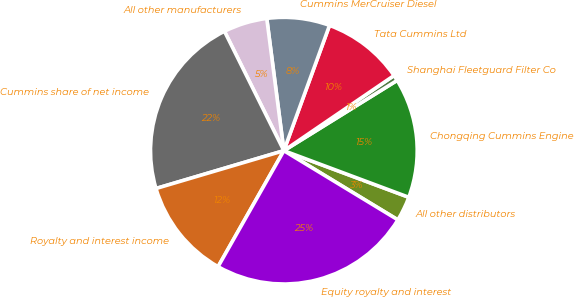Convert chart. <chart><loc_0><loc_0><loc_500><loc_500><pie_chart><fcel>All other distributors<fcel>Chongqing Cummins Engine<fcel>Shanghai Fleetguard Filter Co<fcel>Tata Cummins Ltd<fcel>Cummins MerCruiser Diesel<fcel>All other manufacturers<fcel>Cummins share of net income<fcel>Royalty and interest income<fcel>Equity royalty and interest<nl><fcel>3.0%<fcel>14.52%<fcel>0.69%<fcel>9.91%<fcel>7.61%<fcel>5.3%<fcel>22.23%<fcel>12.21%<fcel>24.53%<nl></chart> 